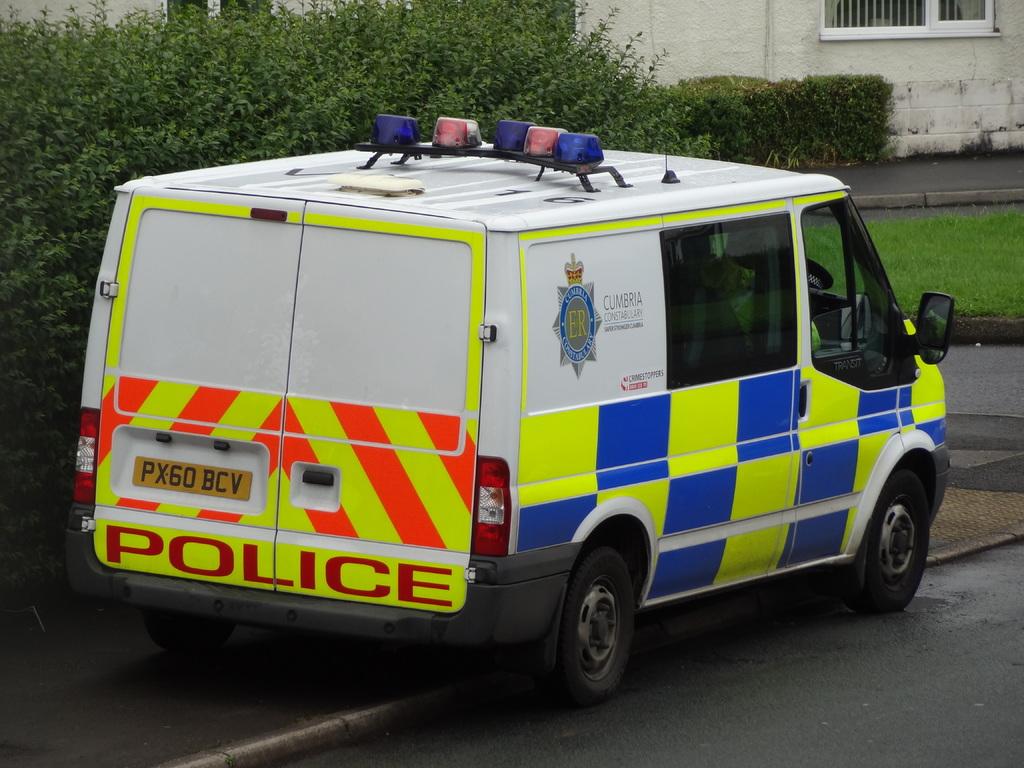What does the license plate say?
Make the answer very short. Px60 bcv. What department does this belong to?
Keep it short and to the point. Police. 